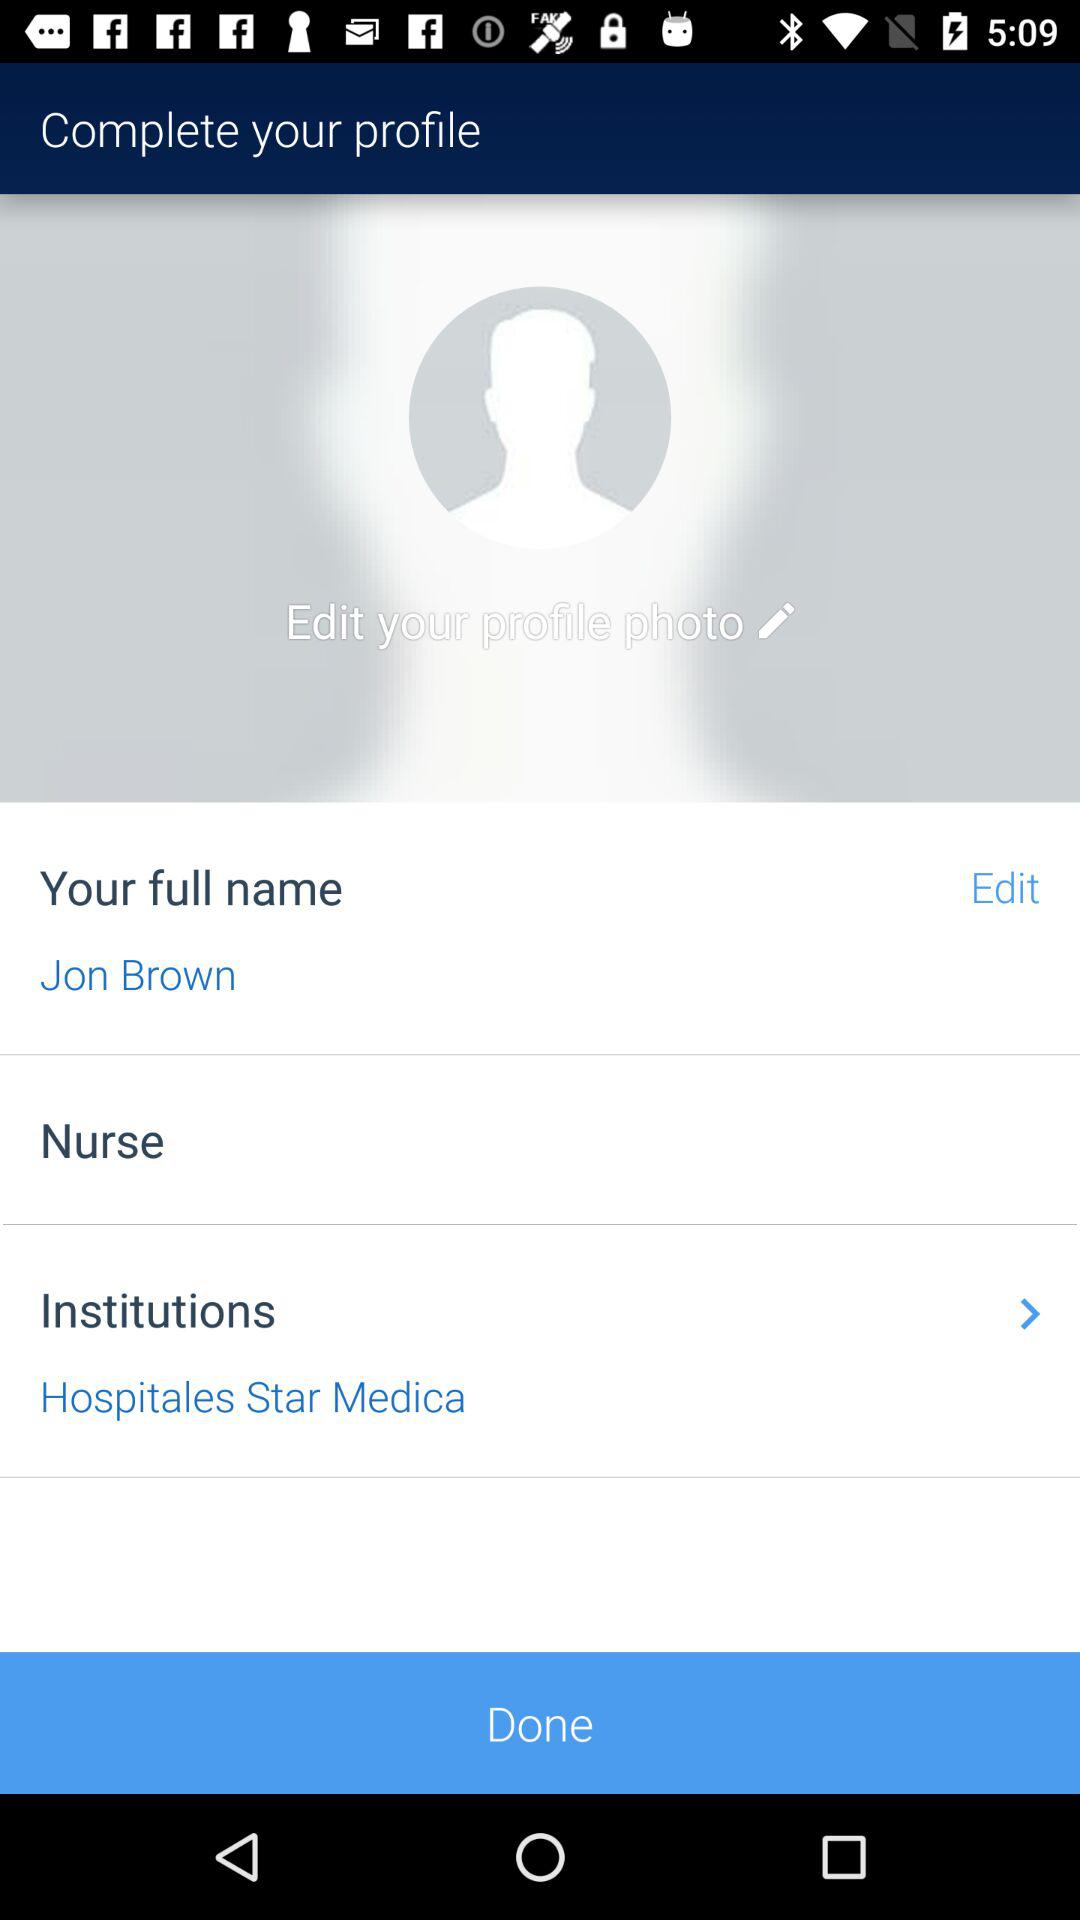What is the name of the institution? The name of the institution is "Hospitales Star Medica". 